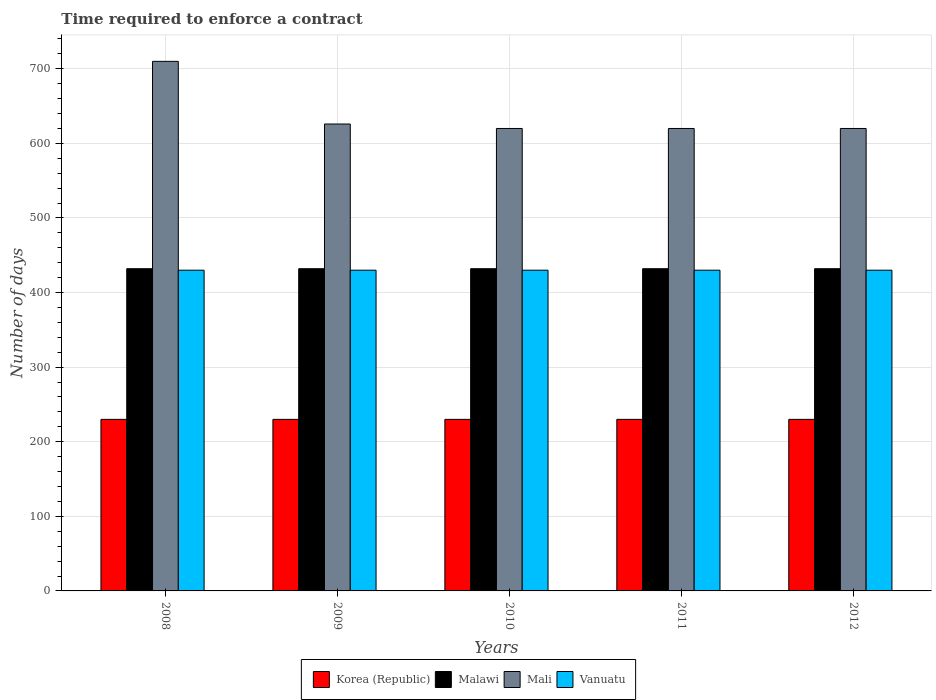How many groups of bars are there?
Offer a terse response. 5. Are the number of bars per tick equal to the number of legend labels?
Ensure brevity in your answer.  Yes. Are the number of bars on each tick of the X-axis equal?
Offer a very short reply. Yes. What is the label of the 2nd group of bars from the left?
Your answer should be compact. 2009. What is the number of days required to enforce a contract in Malawi in 2008?
Offer a terse response. 432. Across all years, what is the maximum number of days required to enforce a contract in Mali?
Your answer should be very brief. 710. Across all years, what is the minimum number of days required to enforce a contract in Vanuatu?
Your answer should be compact. 430. What is the total number of days required to enforce a contract in Korea (Republic) in the graph?
Offer a terse response. 1150. What is the difference between the number of days required to enforce a contract in Vanuatu in 2010 and that in 2011?
Ensure brevity in your answer.  0. What is the difference between the number of days required to enforce a contract in Vanuatu in 2011 and the number of days required to enforce a contract in Mali in 2009?
Ensure brevity in your answer.  -196. What is the average number of days required to enforce a contract in Malawi per year?
Offer a terse response. 432. In the year 2011, what is the difference between the number of days required to enforce a contract in Mali and number of days required to enforce a contract in Korea (Republic)?
Offer a very short reply. 390. What is the ratio of the number of days required to enforce a contract in Mali in 2008 to that in 2012?
Keep it short and to the point. 1.15. What is the difference between the highest and the second highest number of days required to enforce a contract in Korea (Republic)?
Give a very brief answer. 0. In how many years, is the number of days required to enforce a contract in Mali greater than the average number of days required to enforce a contract in Mali taken over all years?
Give a very brief answer. 1. What does the 4th bar from the right in 2008 represents?
Offer a terse response. Korea (Republic). Is it the case that in every year, the sum of the number of days required to enforce a contract in Vanuatu and number of days required to enforce a contract in Mali is greater than the number of days required to enforce a contract in Malawi?
Provide a succinct answer. Yes. Are all the bars in the graph horizontal?
Provide a short and direct response. No. How many years are there in the graph?
Ensure brevity in your answer.  5. Where does the legend appear in the graph?
Give a very brief answer. Bottom center. What is the title of the graph?
Provide a succinct answer. Time required to enforce a contract. What is the label or title of the Y-axis?
Offer a very short reply. Number of days. What is the Number of days of Korea (Republic) in 2008?
Offer a very short reply. 230. What is the Number of days in Malawi in 2008?
Ensure brevity in your answer.  432. What is the Number of days in Mali in 2008?
Provide a succinct answer. 710. What is the Number of days of Vanuatu in 2008?
Your response must be concise. 430. What is the Number of days in Korea (Republic) in 2009?
Your answer should be compact. 230. What is the Number of days in Malawi in 2009?
Keep it short and to the point. 432. What is the Number of days in Mali in 2009?
Your response must be concise. 626. What is the Number of days in Vanuatu in 2009?
Provide a succinct answer. 430. What is the Number of days in Korea (Republic) in 2010?
Your answer should be compact. 230. What is the Number of days of Malawi in 2010?
Offer a very short reply. 432. What is the Number of days of Mali in 2010?
Your response must be concise. 620. What is the Number of days in Vanuatu in 2010?
Ensure brevity in your answer.  430. What is the Number of days of Korea (Republic) in 2011?
Your response must be concise. 230. What is the Number of days of Malawi in 2011?
Provide a short and direct response. 432. What is the Number of days in Mali in 2011?
Ensure brevity in your answer.  620. What is the Number of days in Vanuatu in 2011?
Offer a terse response. 430. What is the Number of days of Korea (Republic) in 2012?
Give a very brief answer. 230. What is the Number of days in Malawi in 2012?
Give a very brief answer. 432. What is the Number of days in Mali in 2012?
Offer a terse response. 620. What is the Number of days in Vanuatu in 2012?
Keep it short and to the point. 430. Across all years, what is the maximum Number of days in Korea (Republic)?
Provide a short and direct response. 230. Across all years, what is the maximum Number of days in Malawi?
Make the answer very short. 432. Across all years, what is the maximum Number of days of Mali?
Provide a short and direct response. 710. Across all years, what is the maximum Number of days of Vanuatu?
Your response must be concise. 430. Across all years, what is the minimum Number of days of Korea (Republic)?
Your answer should be compact. 230. Across all years, what is the minimum Number of days in Malawi?
Provide a short and direct response. 432. Across all years, what is the minimum Number of days in Mali?
Your response must be concise. 620. Across all years, what is the minimum Number of days in Vanuatu?
Offer a very short reply. 430. What is the total Number of days of Korea (Republic) in the graph?
Ensure brevity in your answer.  1150. What is the total Number of days of Malawi in the graph?
Your answer should be very brief. 2160. What is the total Number of days in Mali in the graph?
Provide a short and direct response. 3196. What is the total Number of days in Vanuatu in the graph?
Your answer should be compact. 2150. What is the difference between the Number of days of Korea (Republic) in 2008 and that in 2009?
Offer a very short reply. 0. What is the difference between the Number of days in Mali in 2008 and that in 2009?
Offer a very short reply. 84. What is the difference between the Number of days of Vanuatu in 2008 and that in 2009?
Make the answer very short. 0. What is the difference between the Number of days in Malawi in 2008 and that in 2010?
Keep it short and to the point. 0. What is the difference between the Number of days in Vanuatu in 2008 and that in 2010?
Your answer should be compact. 0. What is the difference between the Number of days in Korea (Republic) in 2008 and that in 2011?
Keep it short and to the point. 0. What is the difference between the Number of days of Malawi in 2008 and that in 2011?
Give a very brief answer. 0. What is the difference between the Number of days of Mali in 2008 and that in 2011?
Give a very brief answer. 90. What is the difference between the Number of days of Vanuatu in 2008 and that in 2011?
Your response must be concise. 0. What is the difference between the Number of days of Malawi in 2008 and that in 2012?
Make the answer very short. 0. What is the difference between the Number of days of Mali in 2008 and that in 2012?
Your answer should be very brief. 90. What is the difference between the Number of days in Vanuatu in 2009 and that in 2010?
Offer a very short reply. 0. What is the difference between the Number of days in Mali in 2009 and that in 2011?
Keep it short and to the point. 6. What is the difference between the Number of days in Korea (Republic) in 2009 and that in 2012?
Keep it short and to the point. 0. What is the difference between the Number of days of Malawi in 2009 and that in 2012?
Offer a very short reply. 0. What is the difference between the Number of days of Mali in 2009 and that in 2012?
Ensure brevity in your answer.  6. What is the difference between the Number of days of Vanuatu in 2009 and that in 2012?
Offer a terse response. 0. What is the difference between the Number of days in Malawi in 2010 and that in 2012?
Your response must be concise. 0. What is the difference between the Number of days in Mali in 2010 and that in 2012?
Ensure brevity in your answer.  0. What is the difference between the Number of days of Vanuatu in 2010 and that in 2012?
Keep it short and to the point. 0. What is the difference between the Number of days in Korea (Republic) in 2011 and that in 2012?
Ensure brevity in your answer.  0. What is the difference between the Number of days of Malawi in 2011 and that in 2012?
Make the answer very short. 0. What is the difference between the Number of days in Korea (Republic) in 2008 and the Number of days in Malawi in 2009?
Your answer should be very brief. -202. What is the difference between the Number of days of Korea (Republic) in 2008 and the Number of days of Mali in 2009?
Provide a short and direct response. -396. What is the difference between the Number of days of Korea (Republic) in 2008 and the Number of days of Vanuatu in 2009?
Provide a short and direct response. -200. What is the difference between the Number of days in Malawi in 2008 and the Number of days in Mali in 2009?
Offer a very short reply. -194. What is the difference between the Number of days in Malawi in 2008 and the Number of days in Vanuatu in 2009?
Make the answer very short. 2. What is the difference between the Number of days of Mali in 2008 and the Number of days of Vanuatu in 2009?
Ensure brevity in your answer.  280. What is the difference between the Number of days of Korea (Republic) in 2008 and the Number of days of Malawi in 2010?
Keep it short and to the point. -202. What is the difference between the Number of days in Korea (Republic) in 2008 and the Number of days in Mali in 2010?
Make the answer very short. -390. What is the difference between the Number of days in Korea (Republic) in 2008 and the Number of days in Vanuatu in 2010?
Provide a succinct answer. -200. What is the difference between the Number of days in Malawi in 2008 and the Number of days in Mali in 2010?
Your answer should be very brief. -188. What is the difference between the Number of days of Malawi in 2008 and the Number of days of Vanuatu in 2010?
Offer a terse response. 2. What is the difference between the Number of days of Mali in 2008 and the Number of days of Vanuatu in 2010?
Offer a terse response. 280. What is the difference between the Number of days of Korea (Republic) in 2008 and the Number of days of Malawi in 2011?
Ensure brevity in your answer.  -202. What is the difference between the Number of days in Korea (Republic) in 2008 and the Number of days in Mali in 2011?
Your answer should be very brief. -390. What is the difference between the Number of days in Korea (Republic) in 2008 and the Number of days in Vanuatu in 2011?
Ensure brevity in your answer.  -200. What is the difference between the Number of days in Malawi in 2008 and the Number of days in Mali in 2011?
Your answer should be very brief. -188. What is the difference between the Number of days of Mali in 2008 and the Number of days of Vanuatu in 2011?
Your answer should be compact. 280. What is the difference between the Number of days of Korea (Republic) in 2008 and the Number of days of Malawi in 2012?
Ensure brevity in your answer.  -202. What is the difference between the Number of days in Korea (Republic) in 2008 and the Number of days in Mali in 2012?
Make the answer very short. -390. What is the difference between the Number of days in Korea (Republic) in 2008 and the Number of days in Vanuatu in 2012?
Offer a very short reply. -200. What is the difference between the Number of days of Malawi in 2008 and the Number of days of Mali in 2012?
Ensure brevity in your answer.  -188. What is the difference between the Number of days in Malawi in 2008 and the Number of days in Vanuatu in 2012?
Offer a very short reply. 2. What is the difference between the Number of days of Mali in 2008 and the Number of days of Vanuatu in 2012?
Give a very brief answer. 280. What is the difference between the Number of days in Korea (Republic) in 2009 and the Number of days in Malawi in 2010?
Provide a succinct answer. -202. What is the difference between the Number of days of Korea (Republic) in 2009 and the Number of days of Mali in 2010?
Offer a terse response. -390. What is the difference between the Number of days in Korea (Republic) in 2009 and the Number of days in Vanuatu in 2010?
Offer a very short reply. -200. What is the difference between the Number of days of Malawi in 2009 and the Number of days of Mali in 2010?
Provide a short and direct response. -188. What is the difference between the Number of days in Malawi in 2009 and the Number of days in Vanuatu in 2010?
Offer a very short reply. 2. What is the difference between the Number of days in Mali in 2009 and the Number of days in Vanuatu in 2010?
Your answer should be very brief. 196. What is the difference between the Number of days of Korea (Republic) in 2009 and the Number of days of Malawi in 2011?
Keep it short and to the point. -202. What is the difference between the Number of days in Korea (Republic) in 2009 and the Number of days in Mali in 2011?
Provide a succinct answer. -390. What is the difference between the Number of days in Korea (Republic) in 2009 and the Number of days in Vanuatu in 2011?
Provide a succinct answer. -200. What is the difference between the Number of days in Malawi in 2009 and the Number of days in Mali in 2011?
Keep it short and to the point. -188. What is the difference between the Number of days of Mali in 2009 and the Number of days of Vanuatu in 2011?
Your answer should be compact. 196. What is the difference between the Number of days in Korea (Republic) in 2009 and the Number of days in Malawi in 2012?
Offer a very short reply. -202. What is the difference between the Number of days in Korea (Republic) in 2009 and the Number of days in Mali in 2012?
Offer a terse response. -390. What is the difference between the Number of days in Korea (Republic) in 2009 and the Number of days in Vanuatu in 2012?
Keep it short and to the point. -200. What is the difference between the Number of days in Malawi in 2009 and the Number of days in Mali in 2012?
Your response must be concise. -188. What is the difference between the Number of days in Mali in 2009 and the Number of days in Vanuatu in 2012?
Ensure brevity in your answer.  196. What is the difference between the Number of days in Korea (Republic) in 2010 and the Number of days in Malawi in 2011?
Provide a succinct answer. -202. What is the difference between the Number of days in Korea (Republic) in 2010 and the Number of days in Mali in 2011?
Give a very brief answer. -390. What is the difference between the Number of days in Korea (Republic) in 2010 and the Number of days in Vanuatu in 2011?
Provide a succinct answer. -200. What is the difference between the Number of days of Malawi in 2010 and the Number of days of Mali in 2011?
Your answer should be compact. -188. What is the difference between the Number of days in Mali in 2010 and the Number of days in Vanuatu in 2011?
Offer a terse response. 190. What is the difference between the Number of days of Korea (Republic) in 2010 and the Number of days of Malawi in 2012?
Provide a succinct answer. -202. What is the difference between the Number of days in Korea (Republic) in 2010 and the Number of days in Mali in 2012?
Provide a succinct answer. -390. What is the difference between the Number of days in Korea (Republic) in 2010 and the Number of days in Vanuatu in 2012?
Make the answer very short. -200. What is the difference between the Number of days of Malawi in 2010 and the Number of days of Mali in 2012?
Ensure brevity in your answer.  -188. What is the difference between the Number of days in Mali in 2010 and the Number of days in Vanuatu in 2012?
Offer a terse response. 190. What is the difference between the Number of days of Korea (Republic) in 2011 and the Number of days of Malawi in 2012?
Keep it short and to the point. -202. What is the difference between the Number of days in Korea (Republic) in 2011 and the Number of days in Mali in 2012?
Give a very brief answer. -390. What is the difference between the Number of days of Korea (Republic) in 2011 and the Number of days of Vanuatu in 2012?
Provide a succinct answer. -200. What is the difference between the Number of days of Malawi in 2011 and the Number of days of Mali in 2012?
Make the answer very short. -188. What is the difference between the Number of days of Mali in 2011 and the Number of days of Vanuatu in 2012?
Offer a terse response. 190. What is the average Number of days in Korea (Republic) per year?
Give a very brief answer. 230. What is the average Number of days in Malawi per year?
Your answer should be very brief. 432. What is the average Number of days in Mali per year?
Offer a very short reply. 639.2. What is the average Number of days in Vanuatu per year?
Keep it short and to the point. 430. In the year 2008, what is the difference between the Number of days in Korea (Republic) and Number of days in Malawi?
Make the answer very short. -202. In the year 2008, what is the difference between the Number of days in Korea (Republic) and Number of days in Mali?
Provide a short and direct response. -480. In the year 2008, what is the difference between the Number of days in Korea (Republic) and Number of days in Vanuatu?
Make the answer very short. -200. In the year 2008, what is the difference between the Number of days of Malawi and Number of days of Mali?
Provide a short and direct response. -278. In the year 2008, what is the difference between the Number of days of Mali and Number of days of Vanuatu?
Your answer should be very brief. 280. In the year 2009, what is the difference between the Number of days of Korea (Republic) and Number of days of Malawi?
Your response must be concise. -202. In the year 2009, what is the difference between the Number of days in Korea (Republic) and Number of days in Mali?
Your answer should be compact. -396. In the year 2009, what is the difference between the Number of days in Korea (Republic) and Number of days in Vanuatu?
Provide a succinct answer. -200. In the year 2009, what is the difference between the Number of days of Malawi and Number of days of Mali?
Your response must be concise. -194. In the year 2009, what is the difference between the Number of days of Mali and Number of days of Vanuatu?
Your answer should be compact. 196. In the year 2010, what is the difference between the Number of days in Korea (Republic) and Number of days in Malawi?
Make the answer very short. -202. In the year 2010, what is the difference between the Number of days in Korea (Republic) and Number of days in Mali?
Provide a short and direct response. -390. In the year 2010, what is the difference between the Number of days of Korea (Republic) and Number of days of Vanuatu?
Provide a short and direct response. -200. In the year 2010, what is the difference between the Number of days in Malawi and Number of days in Mali?
Ensure brevity in your answer.  -188. In the year 2010, what is the difference between the Number of days in Mali and Number of days in Vanuatu?
Make the answer very short. 190. In the year 2011, what is the difference between the Number of days of Korea (Republic) and Number of days of Malawi?
Make the answer very short. -202. In the year 2011, what is the difference between the Number of days in Korea (Republic) and Number of days in Mali?
Provide a succinct answer. -390. In the year 2011, what is the difference between the Number of days in Korea (Republic) and Number of days in Vanuatu?
Ensure brevity in your answer.  -200. In the year 2011, what is the difference between the Number of days of Malawi and Number of days of Mali?
Give a very brief answer. -188. In the year 2011, what is the difference between the Number of days of Mali and Number of days of Vanuatu?
Offer a terse response. 190. In the year 2012, what is the difference between the Number of days in Korea (Republic) and Number of days in Malawi?
Your answer should be very brief. -202. In the year 2012, what is the difference between the Number of days of Korea (Republic) and Number of days of Mali?
Ensure brevity in your answer.  -390. In the year 2012, what is the difference between the Number of days of Korea (Republic) and Number of days of Vanuatu?
Your answer should be compact. -200. In the year 2012, what is the difference between the Number of days in Malawi and Number of days in Mali?
Provide a short and direct response. -188. In the year 2012, what is the difference between the Number of days of Mali and Number of days of Vanuatu?
Your response must be concise. 190. What is the ratio of the Number of days of Mali in 2008 to that in 2009?
Provide a succinct answer. 1.13. What is the ratio of the Number of days of Vanuatu in 2008 to that in 2009?
Ensure brevity in your answer.  1. What is the ratio of the Number of days in Korea (Republic) in 2008 to that in 2010?
Your answer should be compact. 1. What is the ratio of the Number of days of Mali in 2008 to that in 2010?
Provide a succinct answer. 1.15. What is the ratio of the Number of days in Vanuatu in 2008 to that in 2010?
Your answer should be very brief. 1. What is the ratio of the Number of days of Korea (Republic) in 2008 to that in 2011?
Your answer should be compact. 1. What is the ratio of the Number of days in Mali in 2008 to that in 2011?
Keep it short and to the point. 1.15. What is the ratio of the Number of days in Vanuatu in 2008 to that in 2011?
Provide a succinct answer. 1. What is the ratio of the Number of days of Korea (Republic) in 2008 to that in 2012?
Provide a short and direct response. 1. What is the ratio of the Number of days of Mali in 2008 to that in 2012?
Make the answer very short. 1.15. What is the ratio of the Number of days in Korea (Republic) in 2009 to that in 2010?
Offer a very short reply. 1. What is the ratio of the Number of days in Malawi in 2009 to that in 2010?
Offer a terse response. 1. What is the ratio of the Number of days of Mali in 2009 to that in 2010?
Provide a short and direct response. 1.01. What is the ratio of the Number of days of Malawi in 2009 to that in 2011?
Your answer should be compact. 1. What is the ratio of the Number of days of Mali in 2009 to that in 2011?
Keep it short and to the point. 1.01. What is the ratio of the Number of days of Korea (Republic) in 2009 to that in 2012?
Keep it short and to the point. 1. What is the ratio of the Number of days of Malawi in 2009 to that in 2012?
Keep it short and to the point. 1. What is the ratio of the Number of days of Mali in 2009 to that in 2012?
Make the answer very short. 1.01. What is the ratio of the Number of days in Korea (Republic) in 2010 to that in 2011?
Your answer should be compact. 1. What is the ratio of the Number of days in Malawi in 2010 to that in 2011?
Your answer should be very brief. 1. What is the ratio of the Number of days of Vanuatu in 2010 to that in 2011?
Offer a terse response. 1. What is the ratio of the Number of days of Korea (Republic) in 2010 to that in 2012?
Give a very brief answer. 1. What is the ratio of the Number of days of Malawi in 2010 to that in 2012?
Your answer should be compact. 1. What is the ratio of the Number of days of Mali in 2010 to that in 2012?
Provide a succinct answer. 1. What is the ratio of the Number of days in Korea (Republic) in 2011 to that in 2012?
Provide a short and direct response. 1. What is the ratio of the Number of days in Mali in 2011 to that in 2012?
Keep it short and to the point. 1. What is the difference between the highest and the second highest Number of days of Korea (Republic)?
Your response must be concise. 0. What is the difference between the highest and the second highest Number of days in Malawi?
Provide a short and direct response. 0. What is the difference between the highest and the second highest Number of days in Mali?
Keep it short and to the point. 84. What is the difference between the highest and the second highest Number of days of Vanuatu?
Ensure brevity in your answer.  0. What is the difference between the highest and the lowest Number of days of Korea (Republic)?
Provide a short and direct response. 0. What is the difference between the highest and the lowest Number of days of Malawi?
Keep it short and to the point. 0. What is the difference between the highest and the lowest Number of days in Vanuatu?
Give a very brief answer. 0. 